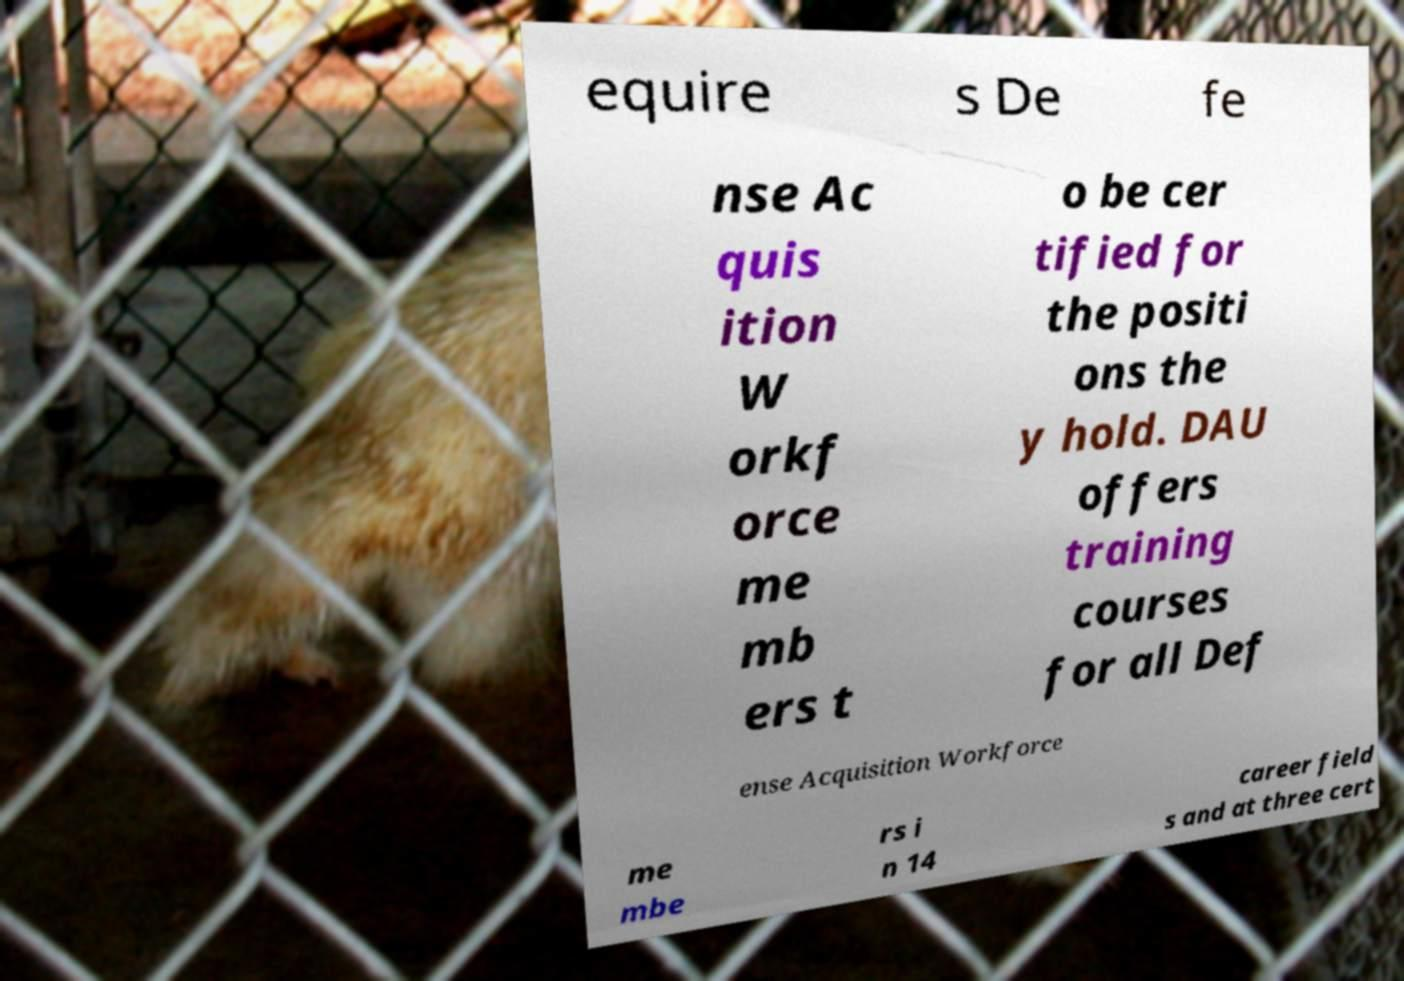I need the written content from this picture converted into text. Can you do that? equire s De fe nse Ac quis ition W orkf orce me mb ers t o be cer tified for the positi ons the y hold. DAU offers training courses for all Def ense Acquisition Workforce me mbe rs i n 14 career field s and at three cert 